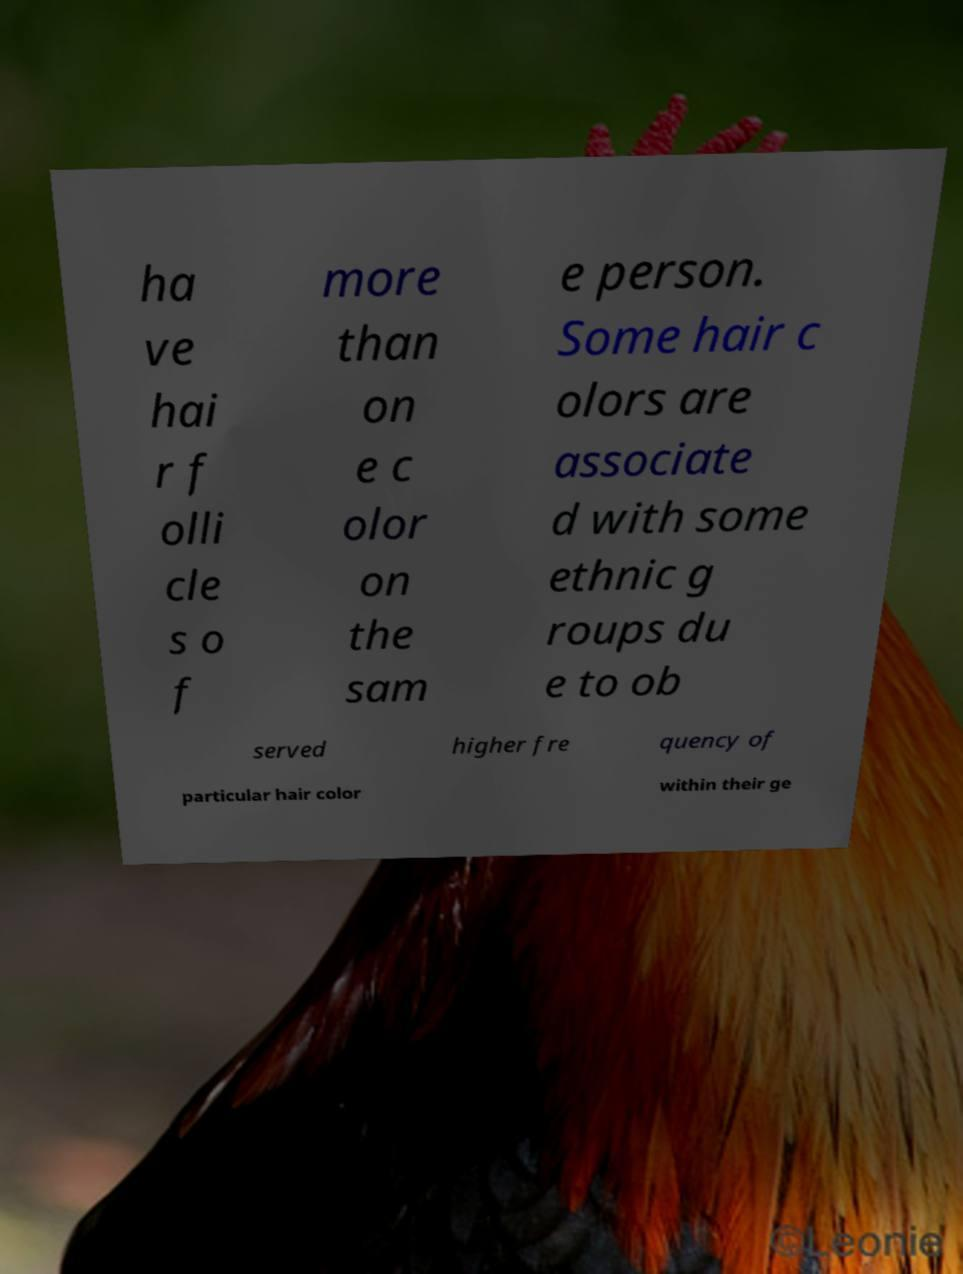There's text embedded in this image that I need extracted. Can you transcribe it verbatim? ha ve hai r f olli cle s o f more than on e c olor on the sam e person. Some hair c olors are associate d with some ethnic g roups du e to ob served higher fre quency of particular hair color within their ge 